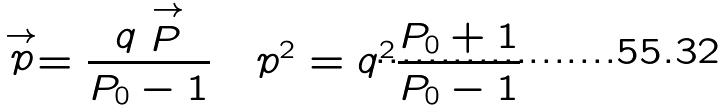Convert formula to latex. <formula><loc_0><loc_0><loc_500><loc_500>\stackrel { \rightarrow } { p } = \frac { q \stackrel { \rightarrow } { P } } { P _ { 0 } - 1 } \quad p ^ { 2 } = q ^ { 2 } \frac { P _ { 0 } + 1 } { P _ { 0 } - 1 }</formula> 